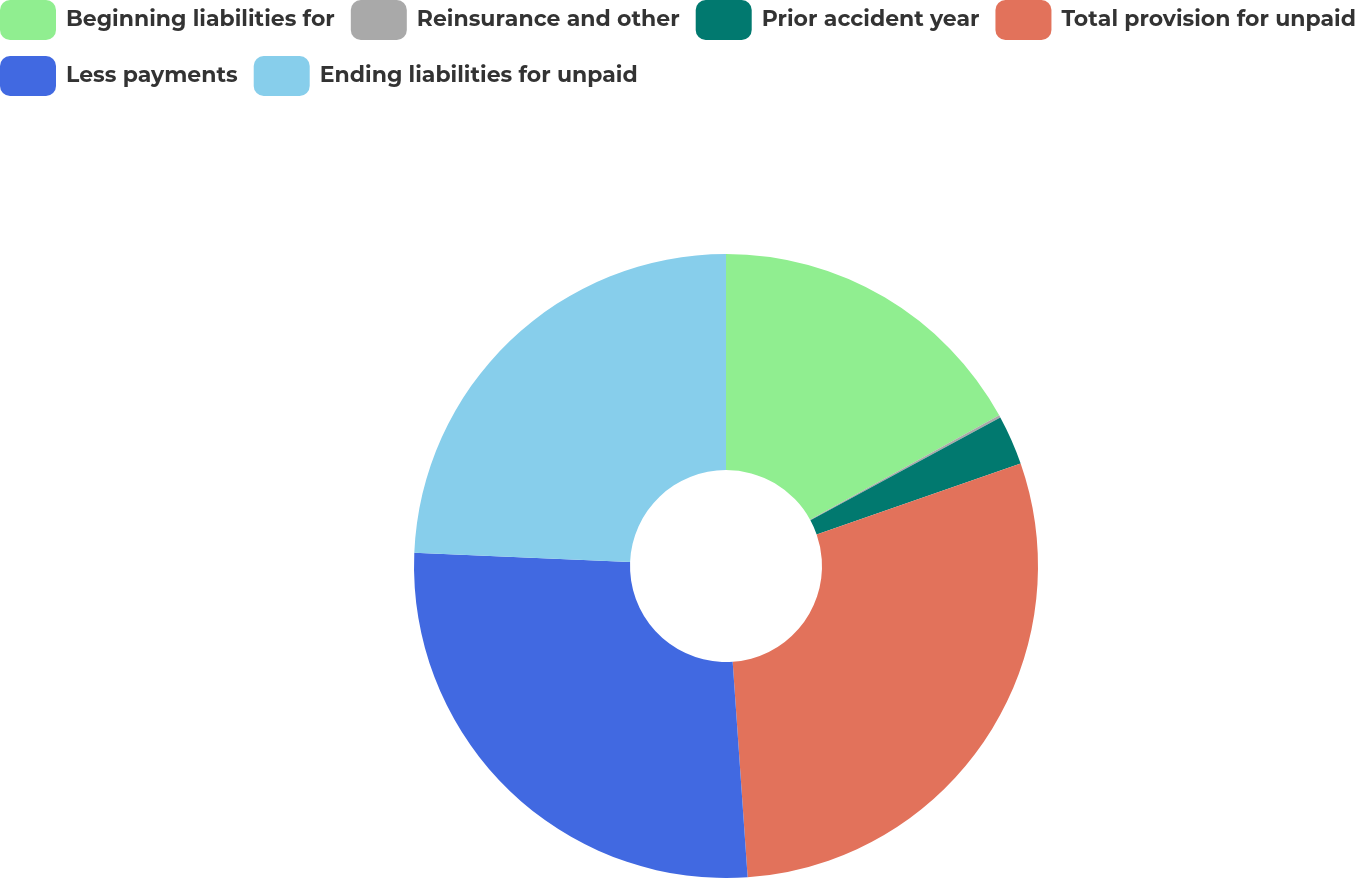<chart> <loc_0><loc_0><loc_500><loc_500><pie_chart><fcel>Beginning liabilities for<fcel>Reinsurance and other<fcel>Prior accident year<fcel>Total provision for unpaid<fcel>Less payments<fcel>Ending liabilities for unpaid<nl><fcel>16.98%<fcel>0.12%<fcel>2.57%<fcel>29.23%<fcel>26.78%<fcel>24.33%<nl></chart> 